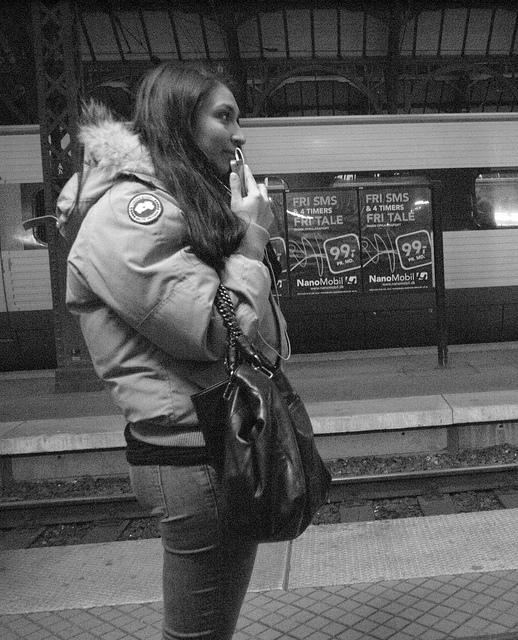Does the woman's jacket have fur on it?
Give a very brief answer. Yes. What is on the woman's arm?
Be succinct. Purse. What color is the bag?
Be succinct. Black. Does the woman appeared to be asian?
Write a very short answer. No. Is the woman smoking?
Concise answer only. No. 